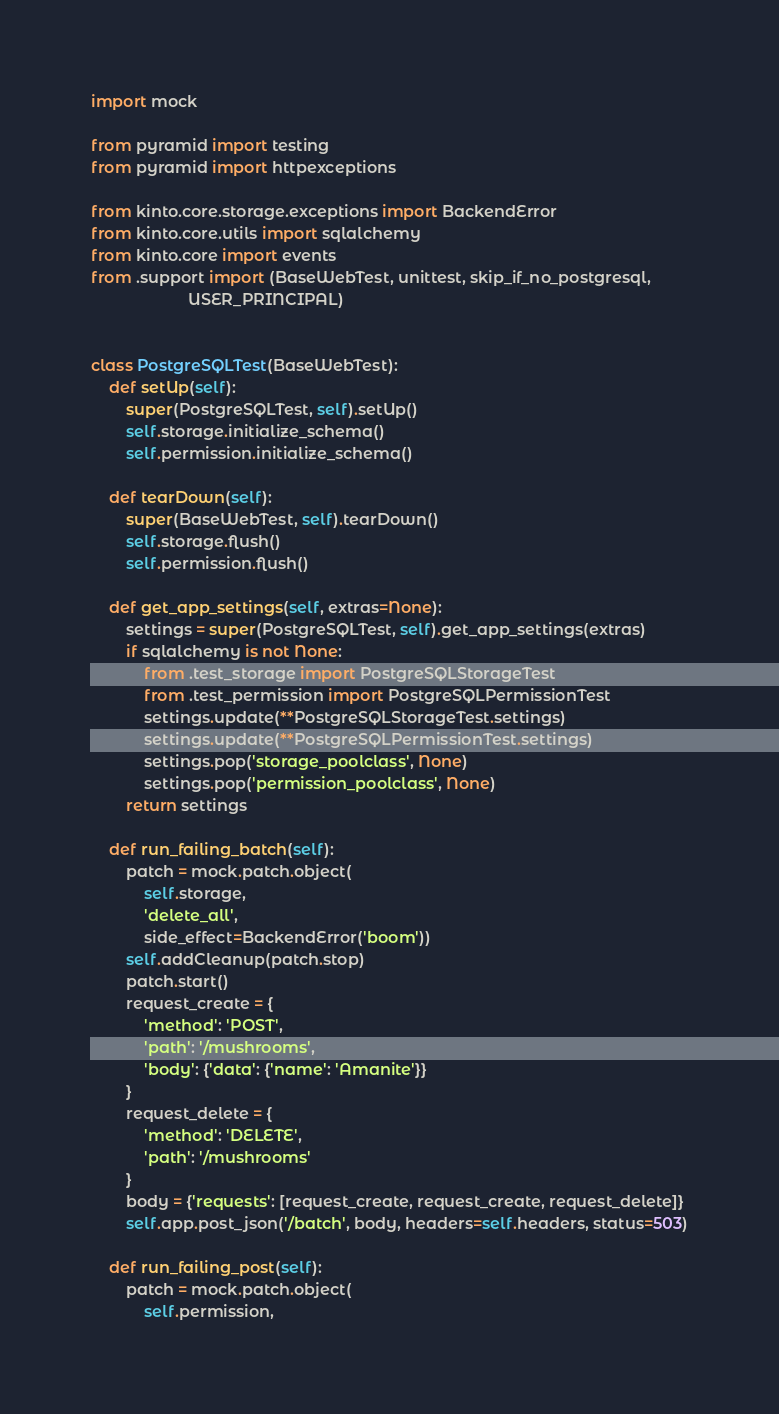<code> <loc_0><loc_0><loc_500><loc_500><_Python_>import mock

from pyramid import testing
from pyramid import httpexceptions

from kinto.core.storage.exceptions import BackendError
from kinto.core.utils import sqlalchemy
from kinto.core import events
from .support import (BaseWebTest, unittest, skip_if_no_postgresql,
                      USER_PRINCIPAL)


class PostgreSQLTest(BaseWebTest):
    def setUp(self):
        super(PostgreSQLTest, self).setUp()
        self.storage.initialize_schema()
        self.permission.initialize_schema()

    def tearDown(self):
        super(BaseWebTest, self).tearDown()
        self.storage.flush()
        self.permission.flush()

    def get_app_settings(self, extras=None):
        settings = super(PostgreSQLTest, self).get_app_settings(extras)
        if sqlalchemy is not None:
            from .test_storage import PostgreSQLStorageTest
            from .test_permission import PostgreSQLPermissionTest
            settings.update(**PostgreSQLStorageTest.settings)
            settings.update(**PostgreSQLPermissionTest.settings)
            settings.pop('storage_poolclass', None)
            settings.pop('permission_poolclass', None)
        return settings

    def run_failing_batch(self):
        patch = mock.patch.object(
            self.storage,
            'delete_all',
            side_effect=BackendError('boom'))
        self.addCleanup(patch.stop)
        patch.start()
        request_create = {
            'method': 'POST',
            'path': '/mushrooms',
            'body': {'data': {'name': 'Amanite'}}
        }
        request_delete = {
            'method': 'DELETE',
            'path': '/mushrooms'
        }
        body = {'requests': [request_create, request_create, request_delete]}
        self.app.post_json('/batch', body, headers=self.headers, status=503)

    def run_failing_post(self):
        patch = mock.patch.object(
            self.permission,</code> 